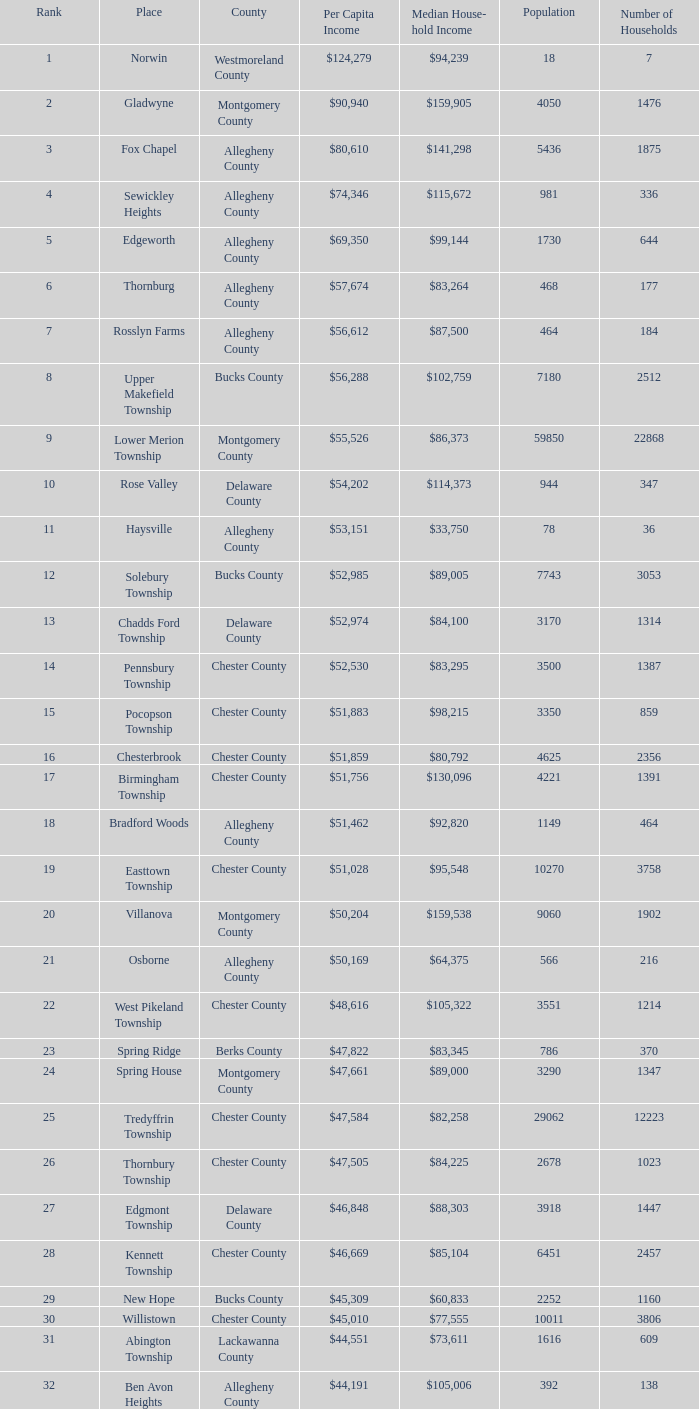What place occupies the ranking of 71? Wyomissing. 